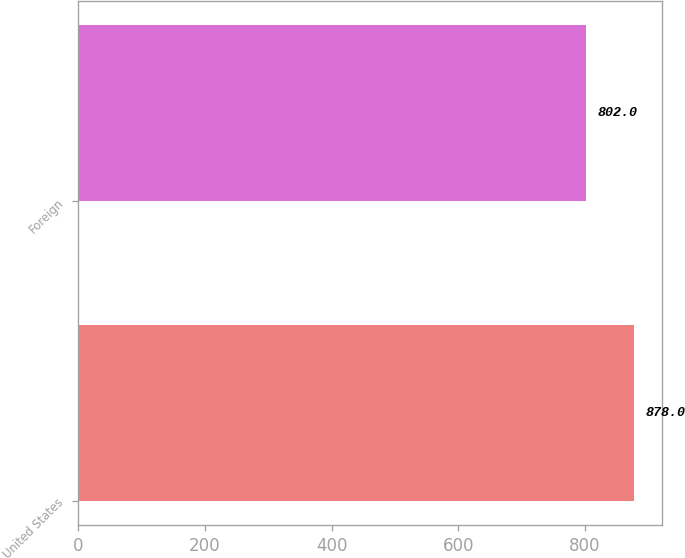Convert chart. <chart><loc_0><loc_0><loc_500><loc_500><bar_chart><fcel>United States<fcel>Foreign<nl><fcel>878<fcel>802<nl></chart> 